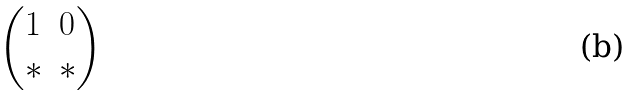Convert formula to latex. <formula><loc_0><loc_0><loc_500><loc_500>\begin{pmatrix} 1 & 0 \\ * & * \end{pmatrix}</formula> 